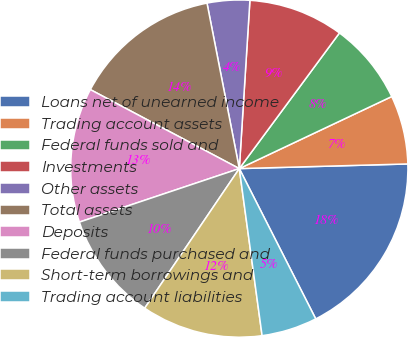<chart> <loc_0><loc_0><loc_500><loc_500><pie_chart><fcel>Loans net of unearned income<fcel>Trading account assets<fcel>Federal funds sold and<fcel>Investments<fcel>Other assets<fcel>Total assets<fcel>Deposits<fcel>Federal funds purchased and<fcel>Short-term borrowings and<fcel>Trading account liabilities<nl><fcel>17.95%<fcel>6.59%<fcel>7.85%<fcel>9.12%<fcel>4.07%<fcel>14.17%<fcel>12.9%<fcel>10.38%<fcel>11.64%<fcel>5.33%<nl></chart> 